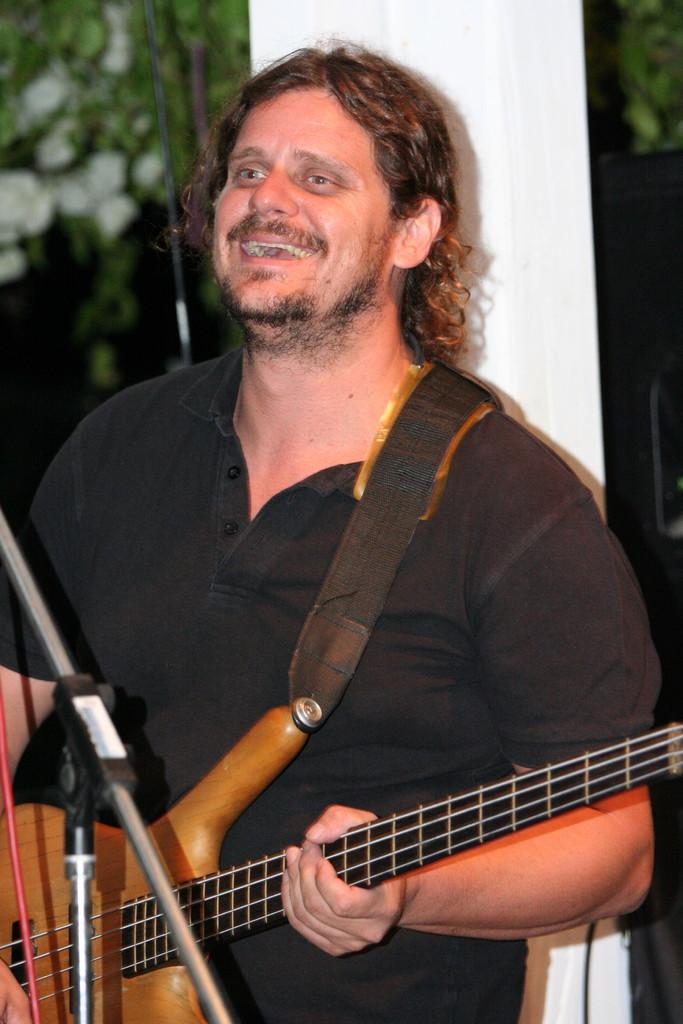What is the man in the image doing? The man in the image is holding a guitar. What is the man's facial expression in the image? The man is smiling in the image. What type of ear can be seen on the guitar in the image? There is no ear present on the guitar in the image. How does the man kick the guitar in the image? The man does not kick the guitar in the image; he is holding it. 